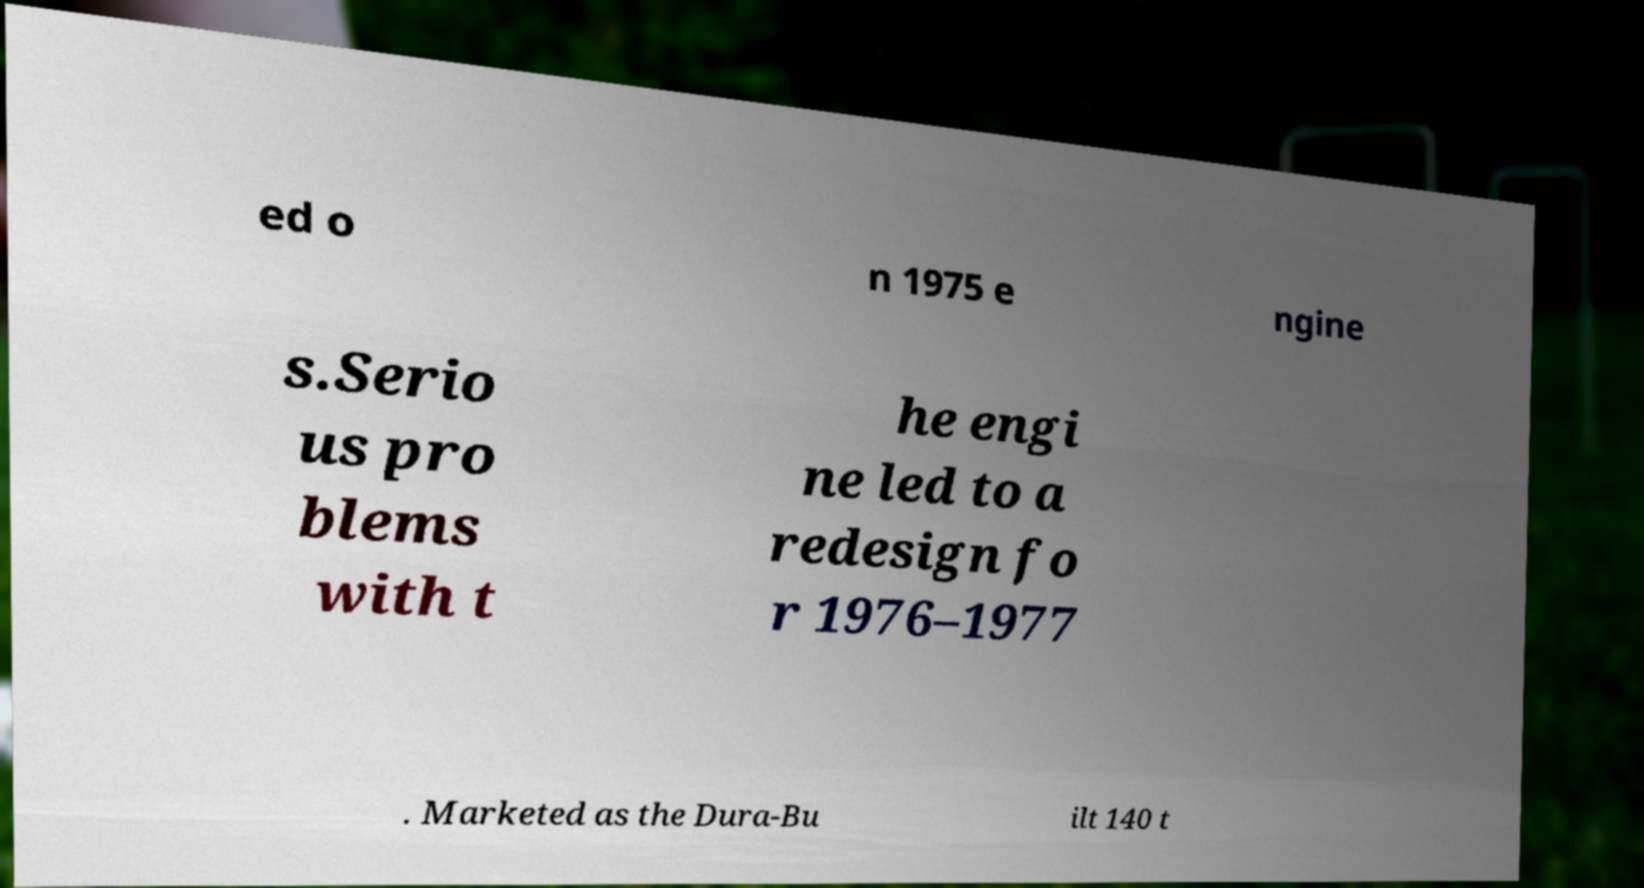For documentation purposes, I need the text within this image transcribed. Could you provide that? ed o n 1975 e ngine s.Serio us pro blems with t he engi ne led to a redesign fo r 1976–1977 . Marketed as the Dura-Bu ilt 140 t 